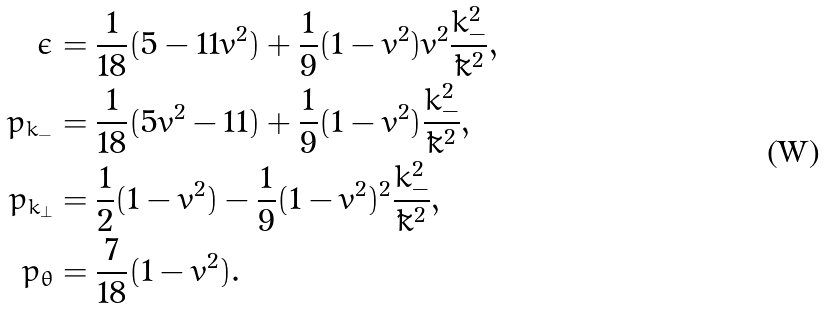Convert formula to latex. <formula><loc_0><loc_0><loc_500><loc_500>\epsilon & = \frac { 1 } { 1 8 } ( 5 - 1 1 v ^ { 2 } ) + \frac { 1 } { 9 } ( 1 - v ^ { 2 } ) v ^ { 2 } \frac { k _ { - } ^ { 2 } } { \tilde { k } ^ { 2 } } , \\ p _ { k _ { - } } & = \frac { 1 } { 1 8 } ( 5 v ^ { 2 } - 1 1 ) + \frac { 1 } { 9 } ( 1 - v ^ { 2 } ) \frac { k _ { - } ^ { 2 } } { \tilde { k } ^ { 2 } } , \\ p _ { k _ { \bot } } & = \frac { 1 } { 2 } ( 1 - v ^ { 2 } ) - \frac { 1 } { 9 } ( 1 - v ^ { 2 } ) ^ { 2 } \frac { k _ { - } ^ { 2 } } { \tilde { k } ^ { 2 } } , \\ p _ { \theta } & = \frac { 7 } { 1 8 } ( 1 - v ^ { 2 } ) .</formula> 